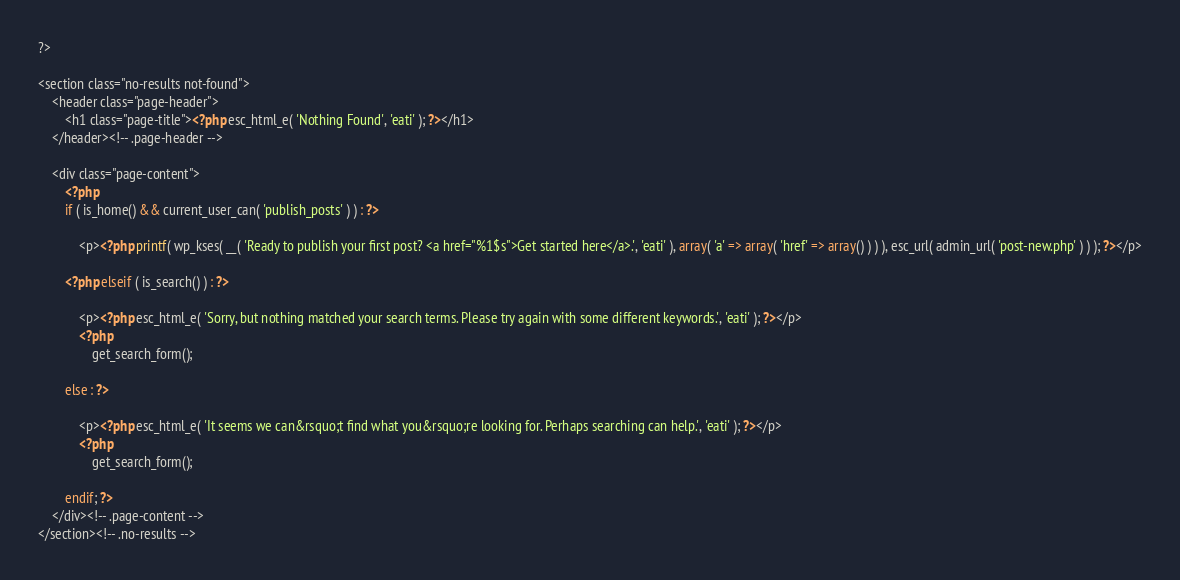<code> <loc_0><loc_0><loc_500><loc_500><_PHP_>?>

<section class="no-results not-found">
	<header class="page-header">
		<h1 class="page-title"><?php esc_html_e( 'Nothing Found', 'eati' ); ?></h1>
	</header><!-- .page-header -->

	<div class="page-content">
		<?php
		if ( is_home() && current_user_can( 'publish_posts' ) ) : ?>

			<p><?php printf( wp_kses( __( 'Ready to publish your first post? <a href="%1$s">Get started here</a>.', 'eati' ), array( 'a' => array( 'href' => array() ) ) ), esc_url( admin_url( 'post-new.php' ) ) ); ?></p>

		<?php elseif ( is_search() ) : ?>

			<p><?php esc_html_e( 'Sorry, but nothing matched your search terms. Please try again with some different keywords.', 'eati' ); ?></p>
			<?php
				get_search_form();

		else : ?>

			<p><?php esc_html_e( 'It seems we can&rsquo;t find what you&rsquo;re looking for. Perhaps searching can help.', 'eati' ); ?></p>
			<?php
				get_search_form();

		endif; ?>
	</div><!-- .page-content -->
</section><!-- .no-results -->
</code> 